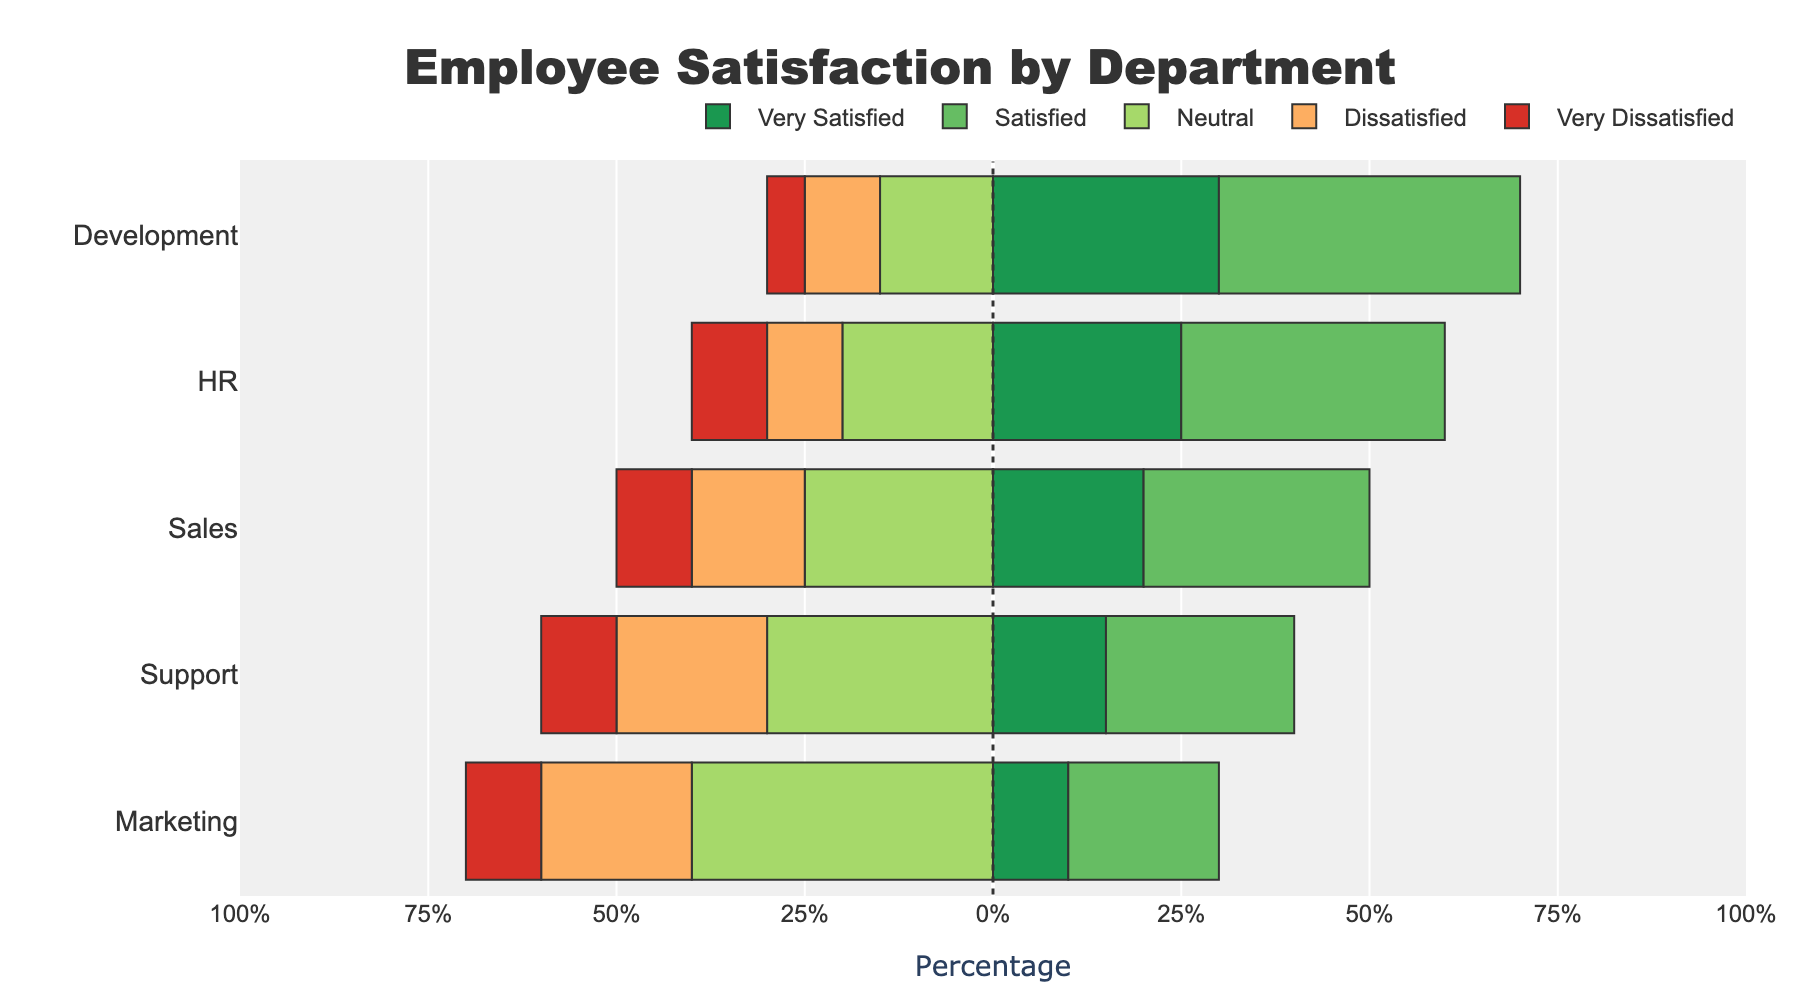Which department has the highest percentage of very satisfied employees? Look for the department with the longest green bar, which represents "Very Satisfied" employees. The Development department has the longest green bar.
Answer: Development What is the combined percentage of dissatisfied and very dissatisfied employees in the Support department? Locate the orange and red bars for the Support department, representing "Dissatisfied" and "Very Dissatisfied" employees, respectively. Add these values: 20% (Dissatisfied) + 10% (Very Dissatisfied).
Answer: 30% Which department has the smallest percentage of neutral employees? Look for the department with the shortest yellow bar for "Neutral" employees. The Development department has the shortest yellow bar.
Answer: Development Compare the percentage of satisfied employees in Sales and Marketing. Which department has a higher percentage and by how much? Identify the blue bars for "Satisfied" employees in Sales and Marketing. Sales has 30% satisfied employees, while Marketing has 20%. The difference is 30% - 20%.
Answer: Sales, by 10% What is the average percentage of very dissatisfied employees across all departments? Find the red bars representing "Very Dissatisfied" for each department and calculate the average: (5% + 10% + 10% + 10% + 10%) / 5.
Answer: 9% For the HR department, what is the difference between the percentage of very satisfied employees and the percentage of dissatisfied employees? Identify the green bar for "Very Satisfied" (25%) and the orange bar for "Dissatisfied" (10%). Subtract the latter from the former: 25% - 10%.
Answer: 15% Which two departments have exactly the same percentage of very dissatisfied employees? Identify red bars representing "Very Dissatisfied" and look for departments with matching lengths. Both Sales and Support have red bars representing 10%.
Answer: Sales and Support In which department is the percentage of neutral employees exactly the same as the combined percentage of very satisfied and satisfied employees? Locate the department where the yellow bar "Neutral" matches the total percentage of green and blue bars "Very Satisfied" and "Satisfied" combined. In Marketing, 40% (Neutral) equals 10% (Very Satisfied) + 20% (Satisfied).
Answer: Marketing Which department has the highest combined percentage of very satisfied and satisfied employees? Add the percentages of "Very Satisfied" (green) and "Satisfied" (blue) employees for each department and identify the highest sum. Development has the highest: 30% (Very Satisfied) + 40% (Satisfied) = 70%.
Answer: Development What is the overall range of percentages (difference between the highest and lowest) of dissatisfied employees across all departments? Identify the smallest and largest orange bars for "Dissatisfied" employees and subtract the smallest from the largest. The smallest is 10% (Development, HR) and the largest is 20% (Support, Marketing), so 20% - 10%.
Answer: 10% 